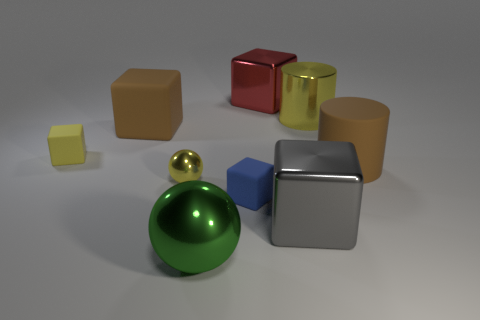Subtract all brown cubes. How many cubes are left? 4 Subtract all red blocks. How many blocks are left? 4 Subtract all green cubes. Subtract all purple spheres. How many cubes are left? 5 Subtract all blocks. How many objects are left? 4 Add 5 tiny yellow matte cubes. How many tiny yellow matte cubes are left? 6 Add 2 small objects. How many small objects exist? 5 Subtract 0 green blocks. How many objects are left? 9 Subtract all matte blocks. Subtract all brown objects. How many objects are left? 4 